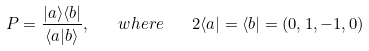<formula> <loc_0><loc_0><loc_500><loc_500>P = \frac { | a \rangle \langle b | } { \langle a | b \rangle } , \quad w h e r e \quad 2 \langle a | = \langle b | = ( 0 , 1 , - 1 , 0 )</formula> 